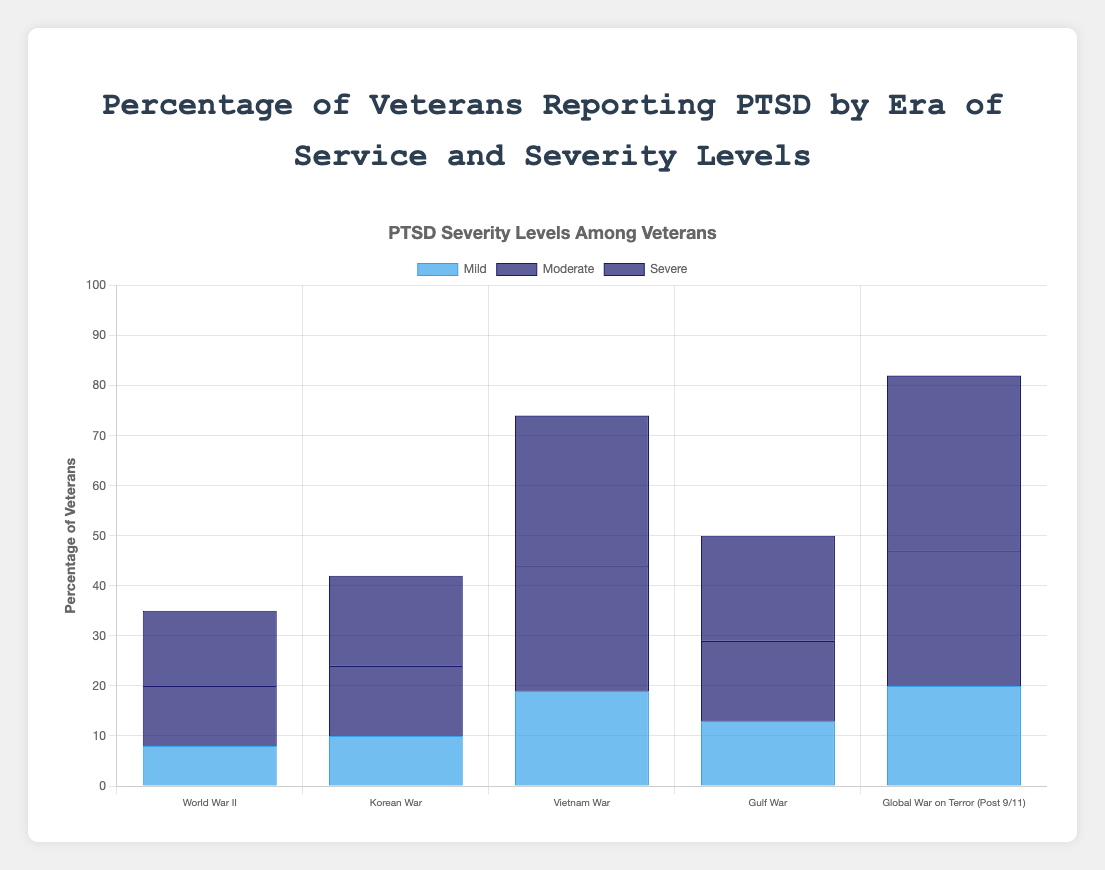Which era has the highest percentage of veterans reporting severe PTSD? The bar indicating the highest percentage in the "Severe" category is the "Global War on Terror (Post 9/11)" era at 35%.
Answer: Global War on Terror (Post 9/11) Which era has the lowest percentage of veterans reporting mild PTSD? The bar indicating the lowest percentage in the "Mild" category is the "World War II" era at 8%.
Answer: World War II What is the total percentage of veterans reporting moderate PTSD in the Gulf War era and the Korean War era? Add the percentages for moderate PTSD in the Gulf War era (16%) and the Korean War era (14%): 16% + 14% = 30%.
Answer: 30% Which era shows the most even distribution across mild, moderate, and severe severity levels? By checking the three bars within each era, the Gulf War era has relatively even percentages: 13% (mild), 16% (moderate), and 21% (severe).
Answer: Gulf War How does the percentage of severe PTSD in the Vietnam War era compare to that in the Korean War era? Compare the "Severe" bars: Vietnam War (30%) is greater than Korean War (18%).
Answer: Vietnam War > Korean War Which eras have at least one category with a percentage greater than 25%? Observing the bars, only the Vietnam War and the Global War on Terror (Post 9/11) eras have at least one category (moderate or severe) with more than 25%.
Answer: Vietnam War, Global War on Terror (Post 9/11) What is the difference in the percentage of mild PTSD between the Global War on Terror (Post 9/11) era and the Korean War era? Subtract the percentages for mild PTSD: 20% (Global War on Terror) - 10% (Korean War) = 10%.
Answer: 10% Considering the severe PTSD levels, what is the percentage increase from the World War II era to the Global War on Terror (Post 9/11) era? Percentage increase = ((35 - 15) / 15) * 100 = 133.33%.
Answer: 133.33% Which two eras have the highest combined percentage of veterans reporting any level of PTSD? Adding the mild, moderate, and severe percentages, the Vietnam War and Global War on Terror (Post 9/11) eras both have combined totals higher than other eras: Vietnam War (19 + 25 + 30 = 74%), Global War on Terror (20 + 27 + 35 = 82%).
Answer: Vietnam War, Global War on Terror (Post 9/11) Across all eras, which severity level has the highest average percentage? Calculate the averages: Mild (8 + 10 + 19 + 13 + 20) / 5 = 14, Moderate (12 + 14 + 25 + 16 + 27) / 5 = 18.8, Severe (15 + 18 + 30 + 21 + 35) / 5 = 23.8. Severe PTSD has the highest average.
Answer: Severe 